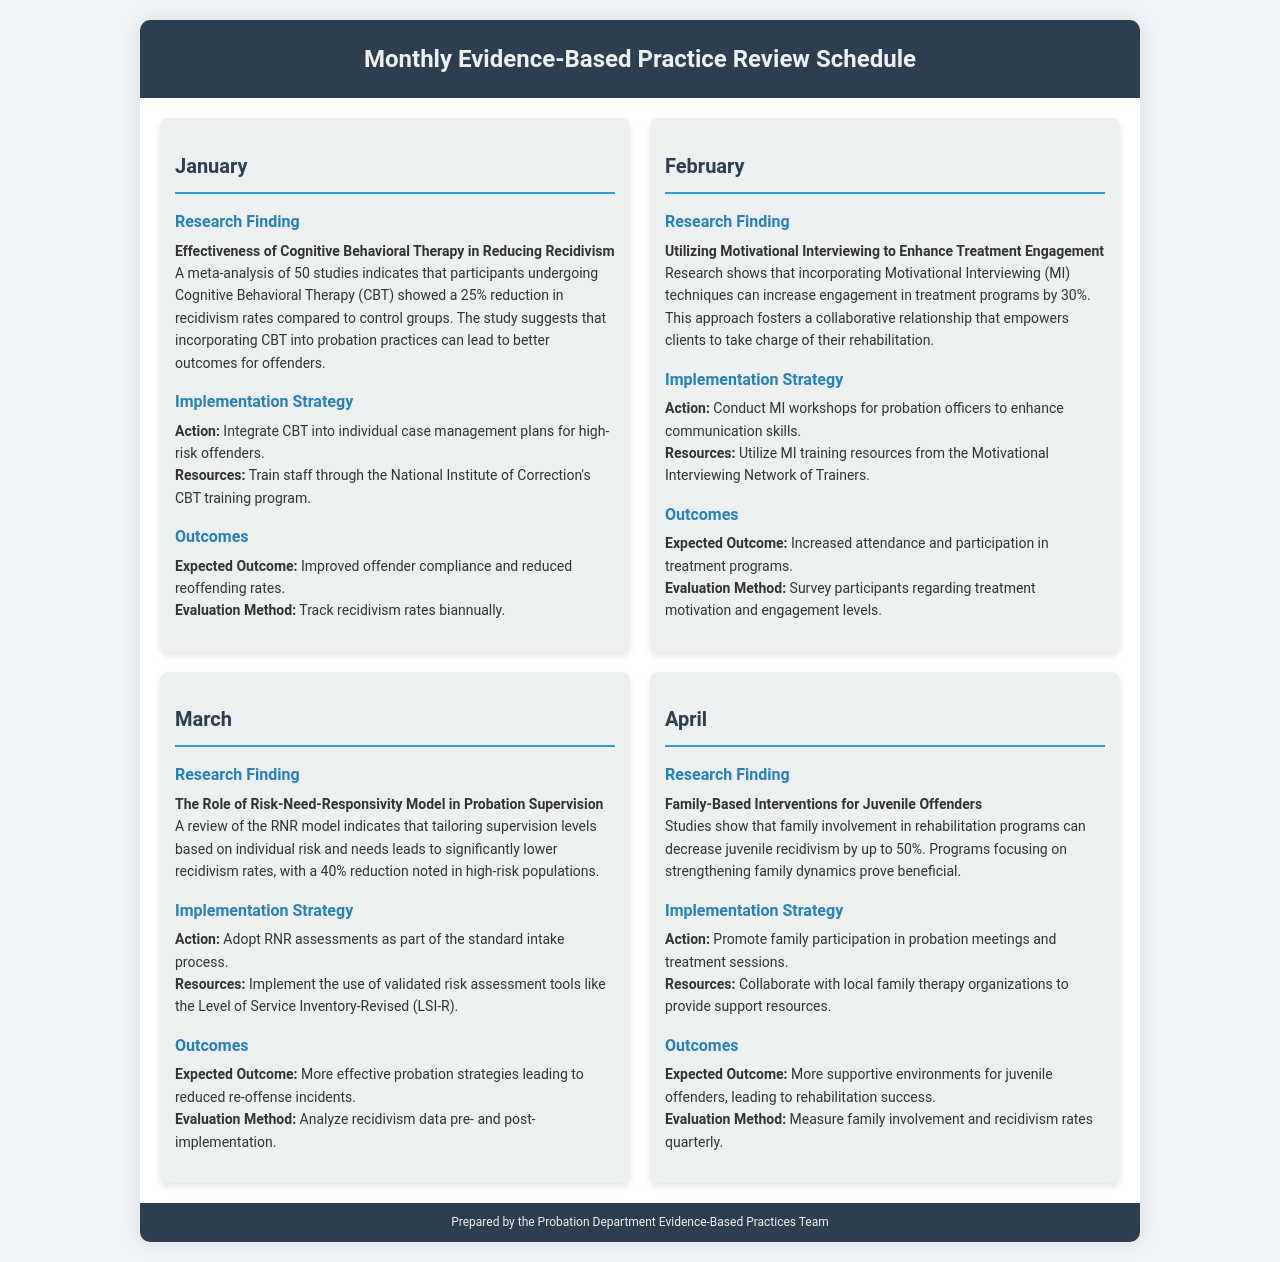What is the focus of the January research finding? The January research finding focuses on the effectiveness of Cognitive Behavioral Therapy in reducing recidivism.
Answer: Cognitive Behavioral Therapy What is the expected outcome for February's implementation strategy? The expected outcome for February is increased attendance and participation in treatment programs.
Answer: Increased attendance and participation What reduction percentage is noted in high-risk populations in March? The document states a 40% reduction in recidivism rates for high-risk populations when using the RNR model.
Answer: 40% Which implementation strategy is proposed for April? The implementation strategy proposed for April is to promote family participation in probation meetings and treatment sessions.
Answer: Promote family participation What technique increased engagement in treatment programs by 30% in February? The technique that increased engagement in treatment programs by 30% is Motivational Interviewing.
Answer: Motivational Interviewing What is the evaluation method for January's expected outcome? The evaluation method for January's expected outcome is to track recidivism rates biannually.
Answer: Track recidivism rates biannually What resources are suggested for the implementation strategy in March? The resources suggested for the implementation strategy in March are validated risk assessment tools like the Level of Service Inventory-Revised.
Answer: Level of Service Inventory-Revised What percentage decrease in juvenile recidivism is noted in April's research finding? The research finding for April notes a decrease in juvenile recidivism by up to 50%.
Answer: 50% What kind of workshops are to be conducted for probation officers in February? The workshops that are to be conducted for probation officers in February are Motivational Interviewing workshops.
Answer: Motivational Interviewing workshops 